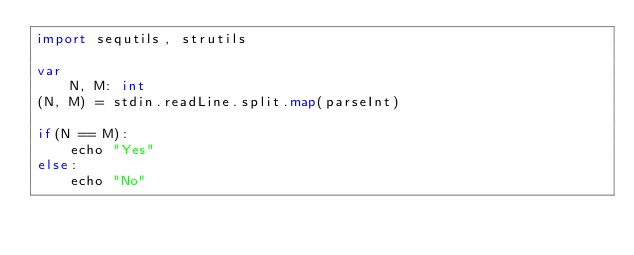Convert code to text. <code><loc_0><loc_0><loc_500><loc_500><_Nim_>import sequtils, strutils

var
    N, M: int
(N, M) = stdin.readLine.split.map(parseInt)

if(N == M):
    echo "Yes"
else:
    echo "No"

</code> 